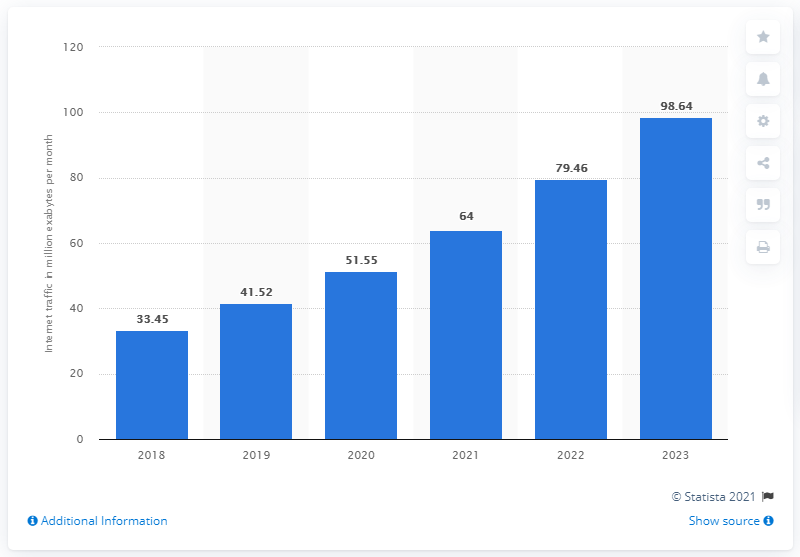List a handful of essential elements in this visual. In 2018, the estimated amount of total internet data traffic per month was approximately 33.45. The estimated internet data traffic per month in the United States was shown by a statistic from 2018 to 2023. 